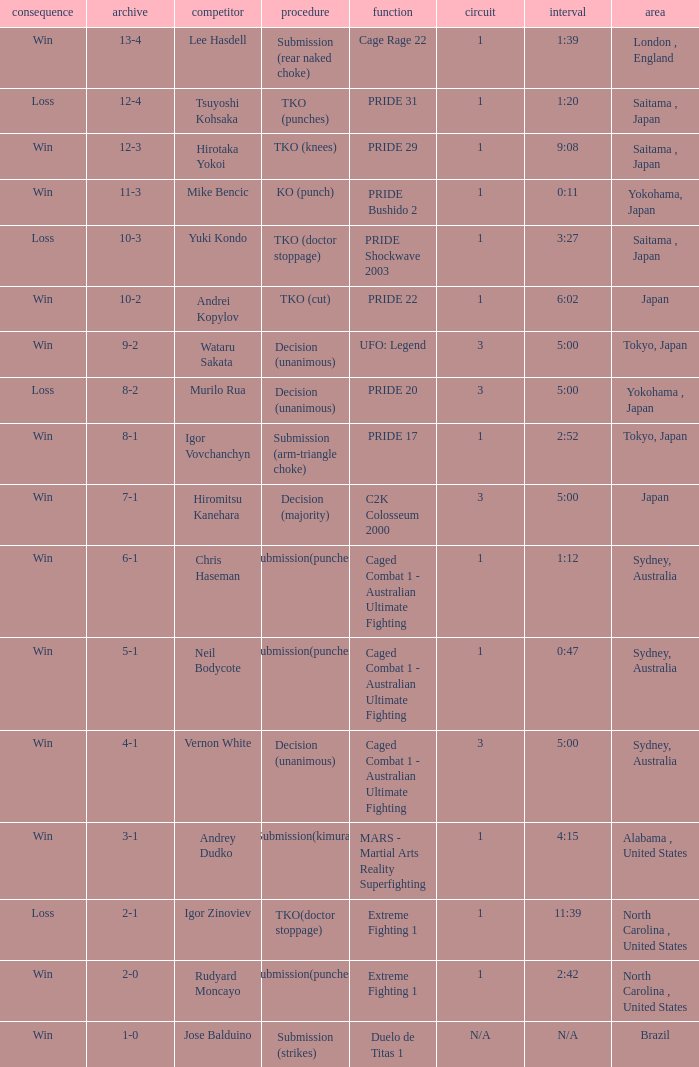Which Res has a Method of decision (unanimous) and an Opponent of Wataru Sakata? Win. 